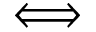<formula> <loc_0><loc_0><loc_500><loc_500>\Longleftrightarrow</formula> 